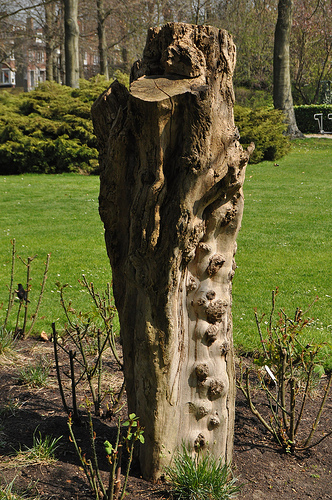<image>
Is there a tree behind the grass? No. The tree is not behind the grass. From this viewpoint, the tree appears to be positioned elsewhere in the scene. Is there a bush in front of the tree? No. The bush is not in front of the tree. The spatial positioning shows a different relationship between these objects. 